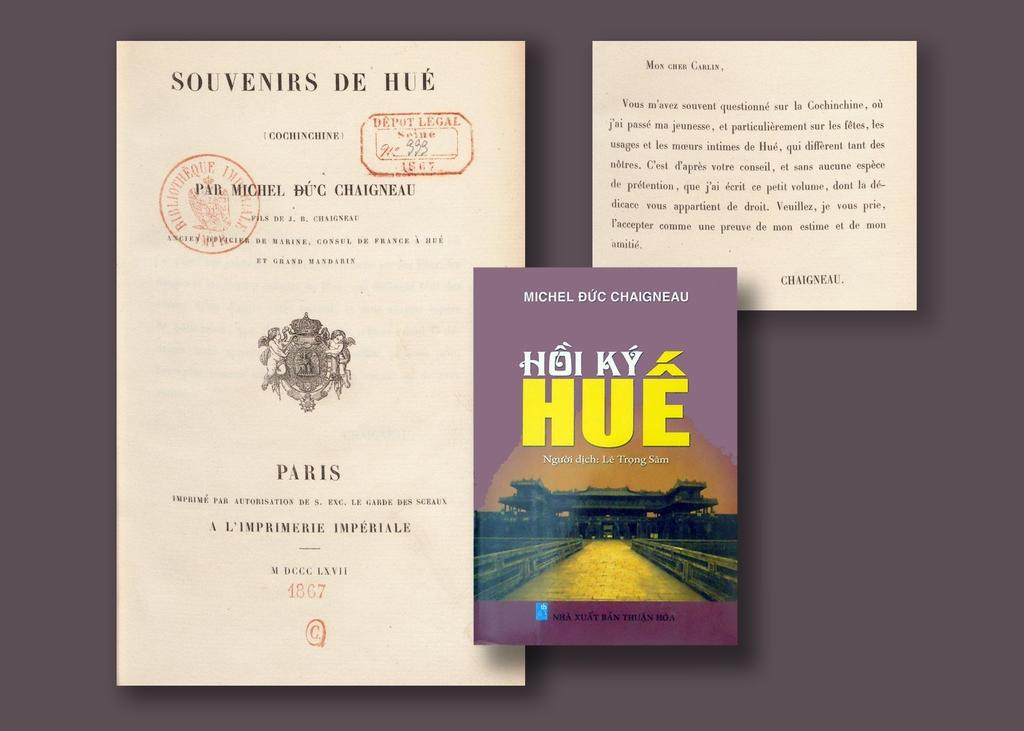<image>
Give a short and clear explanation of the subsequent image. papers that say souvenirs de hue on the top of it 